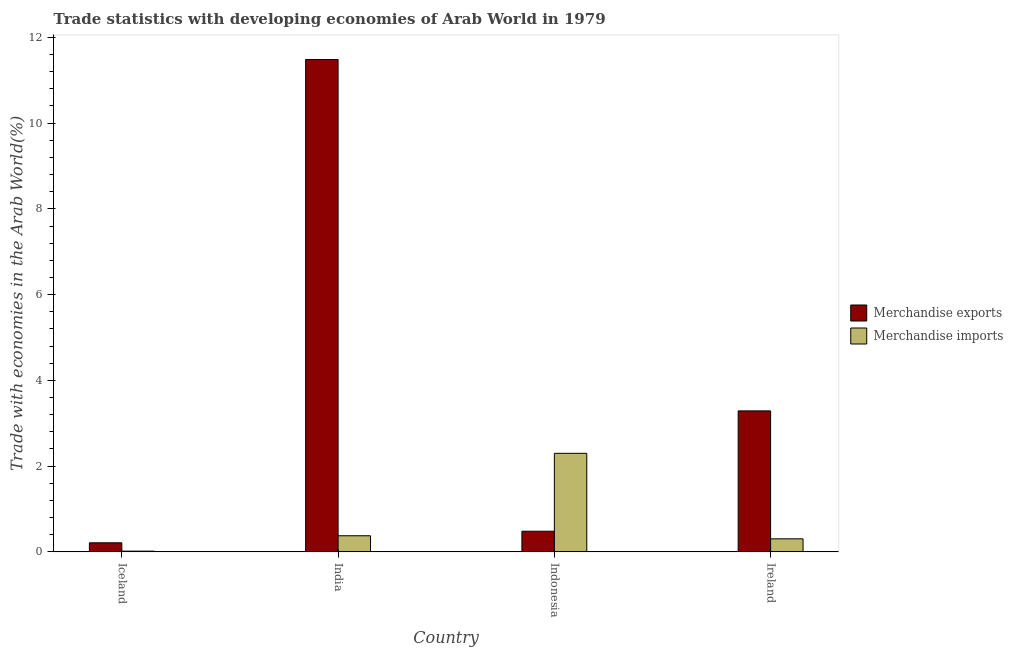How many different coloured bars are there?
Provide a short and direct response. 2. How many groups of bars are there?
Ensure brevity in your answer.  4. Are the number of bars per tick equal to the number of legend labels?
Offer a terse response. Yes. How many bars are there on the 2nd tick from the right?
Offer a very short reply. 2. What is the label of the 4th group of bars from the left?
Your answer should be compact. Ireland. What is the merchandise exports in Ireland?
Give a very brief answer. 3.29. Across all countries, what is the maximum merchandise exports?
Provide a short and direct response. 11.48. Across all countries, what is the minimum merchandise exports?
Your answer should be very brief. 0.21. In which country was the merchandise exports minimum?
Keep it short and to the point. Iceland. What is the total merchandise imports in the graph?
Provide a short and direct response. 3. What is the difference between the merchandise imports in India and that in Ireland?
Your response must be concise. 0.07. What is the difference between the merchandise imports in Indonesia and the merchandise exports in Ireland?
Keep it short and to the point. -0.99. What is the average merchandise exports per country?
Provide a short and direct response. 3.87. What is the difference between the merchandise exports and merchandise imports in Indonesia?
Your answer should be very brief. -1.82. What is the ratio of the merchandise exports in India to that in Ireland?
Ensure brevity in your answer.  3.49. Is the merchandise exports in India less than that in Ireland?
Give a very brief answer. No. Is the difference between the merchandise exports in Iceland and Indonesia greater than the difference between the merchandise imports in Iceland and Indonesia?
Your answer should be very brief. Yes. What is the difference between the highest and the second highest merchandise imports?
Give a very brief answer. 1.92. What is the difference between the highest and the lowest merchandise imports?
Provide a short and direct response. 2.28. In how many countries, is the merchandise exports greater than the average merchandise exports taken over all countries?
Offer a very short reply. 1. Is the sum of the merchandise exports in India and Indonesia greater than the maximum merchandise imports across all countries?
Keep it short and to the point. Yes. What does the 2nd bar from the right in Indonesia represents?
Provide a succinct answer. Merchandise exports. Are all the bars in the graph horizontal?
Provide a succinct answer. No. How many countries are there in the graph?
Make the answer very short. 4. What is the difference between two consecutive major ticks on the Y-axis?
Make the answer very short. 2. Are the values on the major ticks of Y-axis written in scientific E-notation?
Provide a short and direct response. No. Where does the legend appear in the graph?
Your response must be concise. Center right. What is the title of the graph?
Your answer should be compact. Trade statistics with developing economies of Arab World in 1979. Does "Under-five" appear as one of the legend labels in the graph?
Keep it short and to the point. No. What is the label or title of the X-axis?
Provide a succinct answer. Country. What is the label or title of the Y-axis?
Ensure brevity in your answer.  Trade with economies in the Arab World(%). What is the Trade with economies in the Arab World(%) of Merchandise exports in Iceland?
Provide a succinct answer. 0.21. What is the Trade with economies in the Arab World(%) in Merchandise imports in Iceland?
Keep it short and to the point. 0.02. What is the Trade with economies in the Arab World(%) of Merchandise exports in India?
Provide a succinct answer. 11.48. What is the Trade with economies in the Arab World(%) in Merchandise imports in India?
Provide a succinct answer. 0.38. What is the Trade with economies in the Arab World(%) in Merchandise exports in Indonesia?
Your response must be concise. 0.48. What is the Trade with economies in the Arab World(%) in Merchandise imports in Indonesia?
Your response must be concise. 2.3. What is the Trade with economies in the Arab World(%) of Merchandise exports in Ireland?
Your answer should be compact. 3.29. What is the Trade with economies in the Arab World(%) in Merchandise imports in Ireland?
Give a very brief answer. 0.3. Across all countries, what is the maximum Trade with economies in the Arab World(%) in Merchandise exports?
Your response must be concise. 11.48. Across all countries, what is the maximum Trade with economies in the Arab World(%) in Merchandise imports?
Provide a succinct answer. 2.3. Across all countries, what is the minimum Trade with economies in the Arab World(%) of Merchandise exports?
Offer a terse response. 0.21. Across all countries, what is the minimum Trade with economies in the Arab World(%) in Merchandise imports?
Keep it short and to the point. 0.02. What is the total Trade with economies in the Arab World(%) of Merchandise exports in the graph?
Give a very brief answer. 15.47. What is the total Trade with economies in the Arab World(%) of Merchandise imports in the graph?
Keep it short and to the point. 3. What is the difference between the Trade with economies in the Arab World(%) in Merchandise exports in Iceland and that in India?
Provide a short and direct response. -11.27. What is the difference between the Trade with economies in the Arab World(%) of Merchandise imports in Iceland and that in India?
Offer a very short reply. -0.36. What is the difference between the Trade with economies in the Arab World(%) in Merchandise exports in Iceland and that in Indonesia?
Offer a very short reply. -0.27. What is the difference between the Trade with economies in the Arab World(%) in Merchandise imports in Iceland and that in Indonesia?
Provide a succinct answer. -2.28. What is the difference between the Trade with economies in the Arab World(%) of Merchandise exports in Iceland and that in Ireland?
Your response must be concise. -3.08. What is the difference between the Trade with economies in the Arab World(%) in Merchandise imports in Iceland and that in Ireland?
Keep it short and to the point. -0.29. What is the difference between the Trade with economies in the Arab World(%) in Merchandise exports in India and that in Indonesia?
Make the answer very short. 11. What is the difference between the Trade with economies in the Arab World(%) in Merchandise imports in India and that in Indonesia?
Provide a succinct answer. -1.92. What is the difference between the Trade with economies in the Arab World(%) in Merchandise exports in India and that in Ireland?
Your response must be concise. 8.2. What is the difference between the Trade with economies in the Arab World(%) in Merchandise imports in India and that in Ireland?
Provide a short and direct response. 0.07. What is the difference between the Trade with economies in the Arab World(%) in Merchandise exports in Indonesia and that in Ireland?
Your answer should be very brief. -2.81. What is the difference between the Trade with economies in the Arab World(%) in Merchandise imports in Indonesia and that in Ireland?
Your response must be concise. 1.99. What is the difference between the Trade with economies in the Arab World(%) in Merchandise exports in Iceland and the Trade with economies in the Arab World(%) in Merchandise imports in India?
Your answer should be very brief. -0.16. What is the difference between the Trade with economies in the Arab World(%) in Merchandise exports in Iceland and the Trade with economies in the Arab World(%) in Merchandise imports in Indonesia?
Your answer should be very brief. -2.09. What is the difference between the Trade with economies in the Arab World(%) of Merchandise exports in Iceland and the Trade with economies in the Arab World(%) of Merchandise imports in Ireland?
Make the answer very short. -0.09. What is the difference between the Trade with economies in the Arab World(%) of Merchandise exports in India and the Trade with economies in the Arab World(%) of Merchandise imports in Indonesia?
Ensure brevity in your answer.  9.19. What is the difference between the Trade with economies in the Arab World(%) of Merchandise exports in India and the Trade with economies in the Arab World(%) of Merchandise imports in Ireland?
Ensure brevity in your answer.  11.18. What is the difference between the Trade with economies in the Arab World(%) of Merchandise exports in Indonesia and the Trade with economies in the Arab World(%) of Merchandise imports in Ireland?
Give a very brief answer. 0.18. What is the average Trade with economies in the Arab World(%) in Merchandise exports per country?
Your answer should be compact. 3.87. What is the average Trade with economies in the Arab World(%) in Merchandise imports per country?
Provide a succinct answer. 0.75. What is the difference between the Trade with economies in the Arab World(%) in Merchandise exports and Trade with economies in the Arab World(%) in Merchandise imports in Iceland?
Keep it short and to the point. 0.19. What is the difference between the Trade with economies in the Arab World(%) in Merchandise exports and Trade with economies in the Arab World(%) in Merchandise imports in India?
Your answer should be very brief. 11.11. What is the difference between the Trade with economies in the Arab World(%) of Merchandise exports and Trade with economies in the Arab World(%) of Merchandise imports in Indonesia?
Ensure brevity in your answer.  -1.82. What is the difference between the Trade with economies in the Arab World(%) in Merchandise exports and Trade with economies in the Arab World(%) in Merchandise imports in Ireland?
Offer a terse response. 2.98. What is the ratio of the Trade with economies in the Arab World(%) of Merchandise exports in Iceland to that in India?
Provide a short and direct response. 0.02. What is the ratio of the Trade with economies in the Arab World(%) in Merchandise imports in Iceland to that in India?
Your response must be concise. 0.05. What is the ratio of the Trade with economies in the Arab World(%) of Merchandise exports in Iceland to that in Indonesia?
Your answer should be compact. 0.44. What is the ratio of the Trade with economies in the Arab World(%) in Merchandise imports in Iceland to that in Indonesia?
Make the answer very short. 0.01. What is the ratio of the Trade with economies in the Arab World(%) in Merchandise exports in Iceland to that in Ireland?
Provide a succinct answer. 0.06. What is the ratio of the Trade with economies in the Arab World(%) of Merchandise imports in Iceland to that in Ireland?
Offer a terse response. 0.06. What is the ratio of the Trade with economies in the Arab World(%) of Merchandise exports in India to that in Indonesia?
Offer a very short reply. 23.85. What is the ratio of the Trade with economies in the Arab World(%) of Merchandise imports in India to that in Indonesia?
Offer a terse response. 0.16. What is the ratio of the Trade with economies in the Arab World(%) of Merchandise exports in India to that in Ireland?
Your response must be concise. 3.49. What is the ratio of the Trade with economies in the Arab World(%) in Merchandise imports in India to that in Ireland?
Give a very brief answer. 1.23. What is the ratio of the Trade with economies in the Arab World(%) of Merchandise exports in Indonesia to that in Ireland?
Keep it short and to the point. 0.15. What is the ratio of the Trade with economies in the Arab World(%) of Merchandise imports in Indonesia to that in Ireland?
Your answer should be very brief. 7.55. What is the difference between the highest and the second highest Trade with economies in the Arab World(%) in Merchandise exports?
Offer a terse response. 8.2. What is the difference between the highest and the second highest Trade with economies in the Arab World(%) in Merchandise imports?
Make the answer very short. 1.92. What is the difference between the highest and the lowest Trade with economies in the Arab World(%) of Merchandise exports?
Ensure brevity in your answer.  11.27. What is the difference between the highest and the lowest Trade with economies in the Arab World(%) in Merchandise imports?
Give a very brief answer. 2.28. 